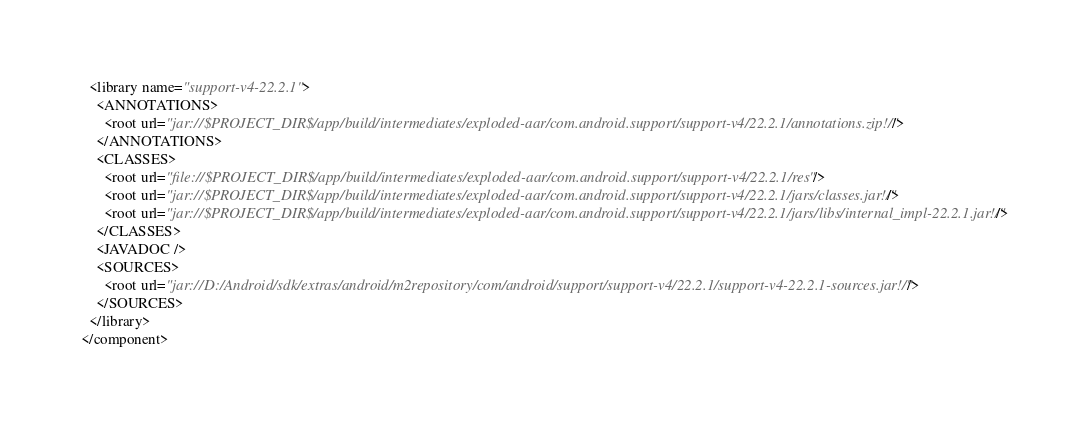Convert code to text. <code><loc_0><loc_0><loc_500><loc_500><_XML_>  <library name="support-v4-22.2.1">
    <ANNOTATIONS>
      <root url="jar://$PROJECT_DIR$/app/build/intermediates/exploded-aar/com.android.support/support-v4/22.2.1/annotations.zip!/" />
    </ANNOTATIONS>
    <CLASSES>
      <root url="file://$PROJECT_DIR$/app/build/intermediates/exploded-aar/com.android.support/support-v4/22.2.1/res" />
      <root url="jar://$PROJECT_DIR$/app/build/intermediates/exploded-aar/com.android.support/support-v4/22.2.1/jars/classes.jar!/" />
      <root url="jar://$PROJECT_DIR$/app/build/intermediates/exploded-aar/com.android.support/support-v4/22.2.1/jars/libs/internal_impl-22.2.1.jar!/" />
    </CLASSES>
    <JAVADOC />
    <SOURCES>
      <root url="jar://D:/Android/sdk/extras/android/m2repository/com/android/support/support-v4/22.2.1/support-v4-22.2.1-sources.jar!/" />
    </SOURCES>
  </library>
</component></code> 